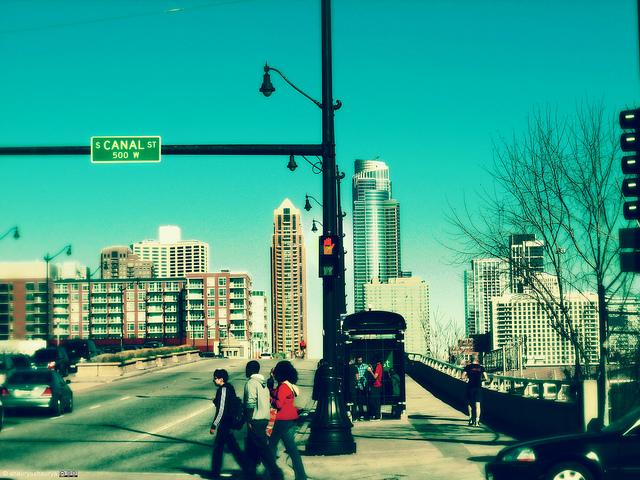How many people are walking across the road?
Concise answer only. 3. How many lanes are on the street?
Quick response, please. 3. What street is this?
Concise answer only. Canal. 